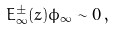Convert formula to latex. <formula><loc_0><loc_0><loc_500><loc_500>E _ { \infty } ^ { \pm } ( z ) \phi _ { \infty } \sim 0 \, ,</formula> 